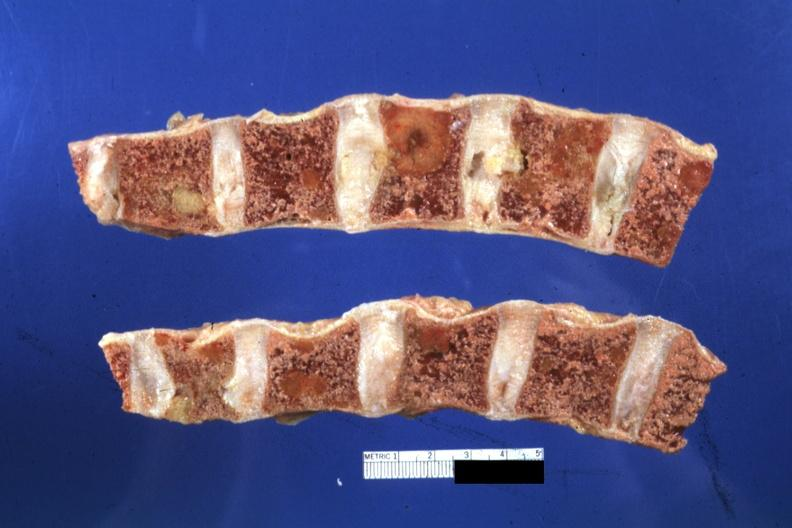what is present?
Answer the question using a single word or phrase. Joints 